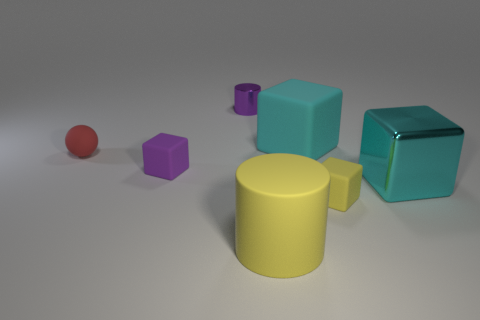Subtract all matte cubes. How many cubes are left? 1 Subtract all red balls. How many cyan blocks are left? 2 Add 3 small purple cubes. How many objects exist? 10 Subtract all purple cubes. How many cubes are left? 3 Subtract all spheres. How many objects are left? 6 Subtract all brown blocks. Subtract all purple balls. How many blocks are left? 4 Subtract 1 red spheres. How many objects are left? 6 Subtract all yellow cubes. Subtract all tiny red rubber balls. How many objects are left? 5 Add 2 purple matte objects. How many purple matte objects are left? 3 Add 6 tiny rubber blocks. How many tiny rubber blocks exist? 8 